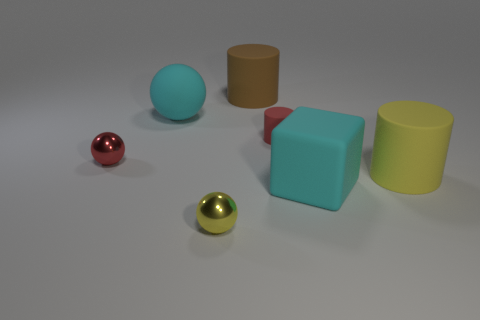Are there the same number of yellow cylinders that are to the left of the red shiny sphere and tiny cyan metallic things? Upon inspecting the image, it is not possible to verify if there are any tiny cyan metallic objects at all and the positioning of the yellow cylinders in relation to the red shiny sphere is also unclear. Thus, an accurate comparison cannot be determined from the current viewpoint. 